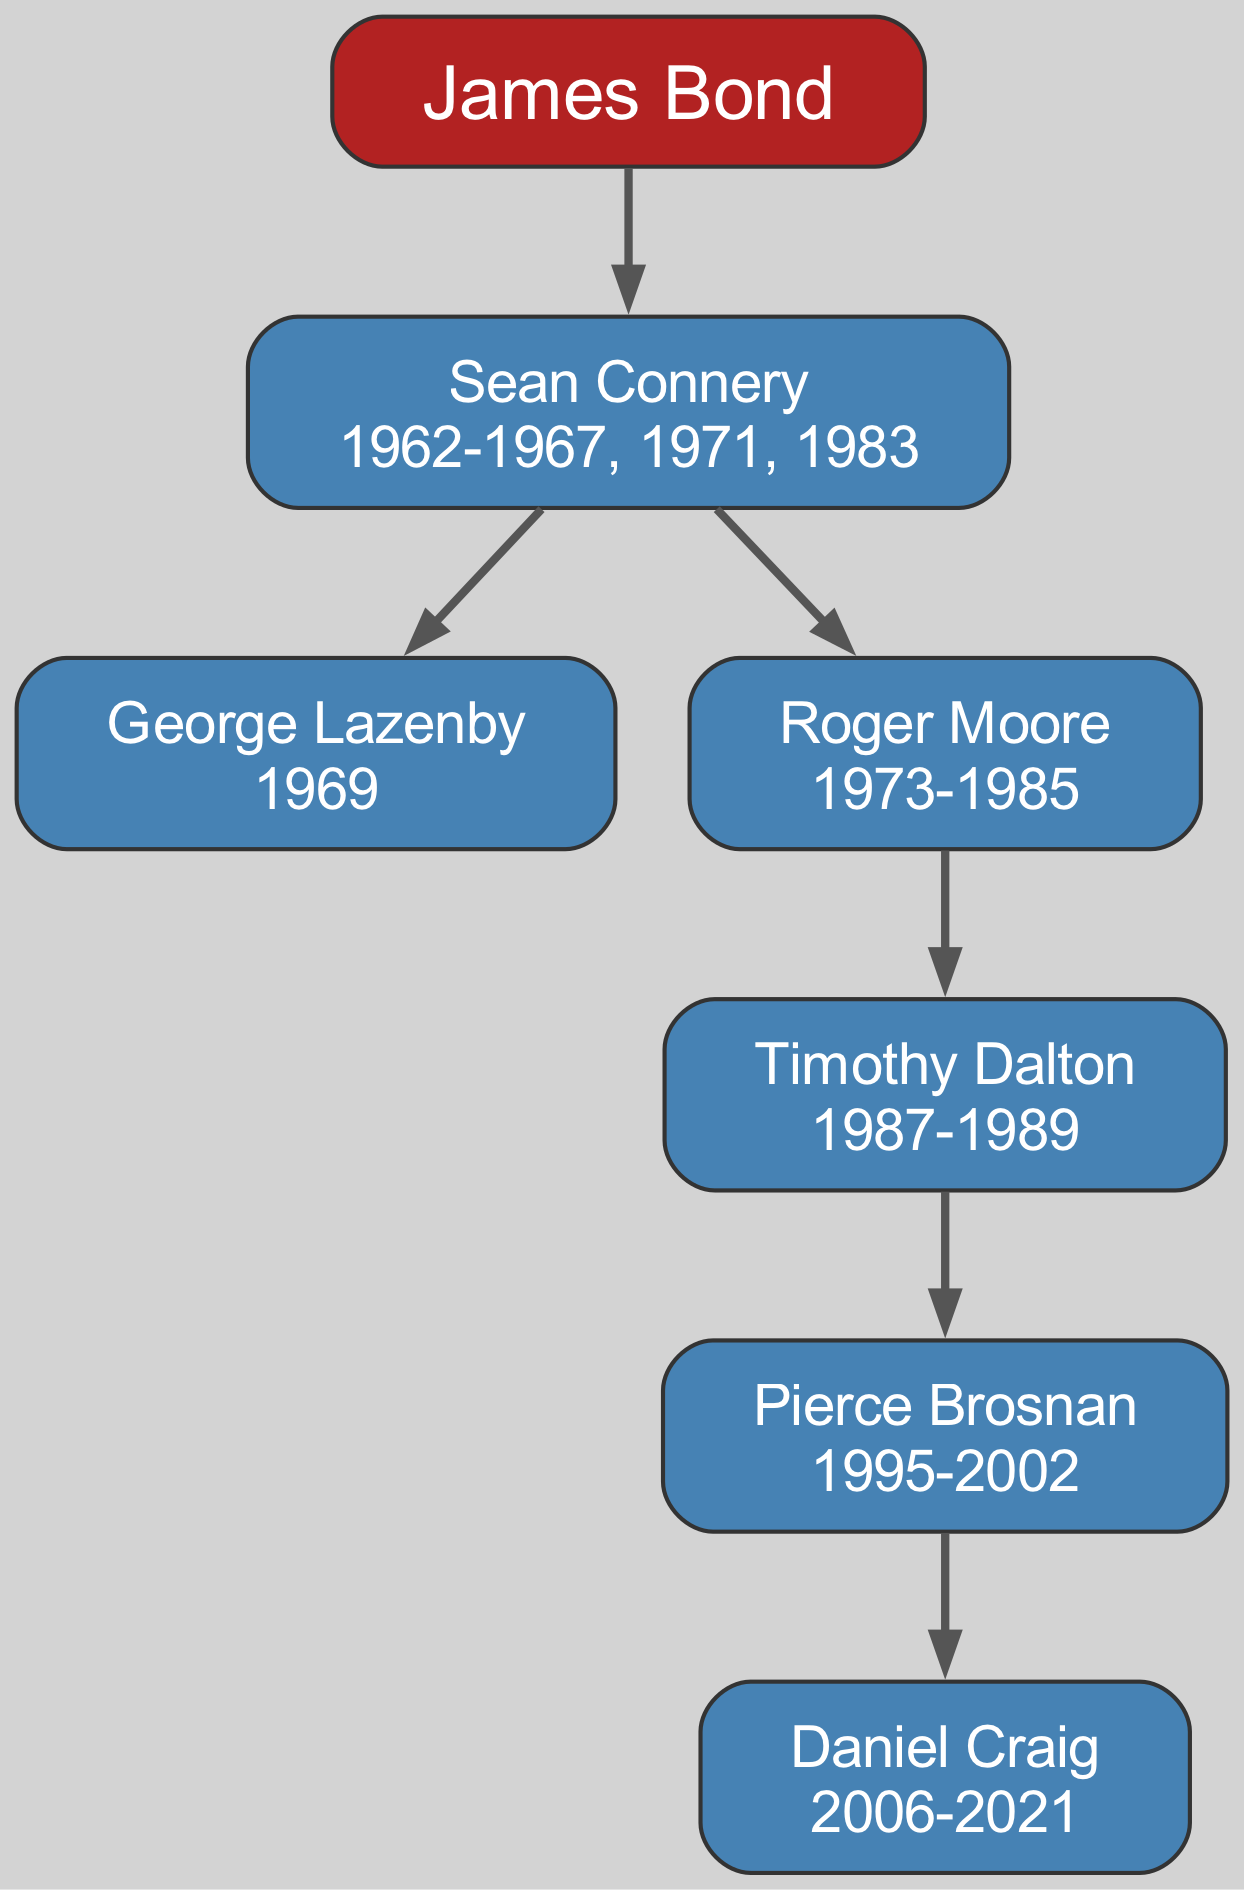What iconic character do these actors portray? The root of the family tree is "James Bond," indicating that all the actors listed are portrayals of this iconic character.
Answer: James Bond How many actors have played James Bond? By tracing the nodes of the diagram from the root to the leaves, we can count the distinct actors: Sean Connery, George Lazenby, Roger Moore, Timothy Dalton, Pierce Brosnan, and Daniel Craig. This totals six actors.
Answer: 6 Who played James Bond before Roger Moore? To find out who portrayed James Bond before Roger Moore, we look at the child nodes of Sean Connery, where George Lazenby is noted as the successor before Roger Moore took over.
Answer: George Lazenby How long did Daniel Craig play James Bond? The years associated with Daniel Craig in the diagram show "2006-2021." To determine the period, we can infer he played the role for approximately 15 years.
Answer: 15 years Which actor has the longest tenure as James Bond? Looking at the years associated with each actor, Sean Connery has the longest coverage of "1962-1967, 1971, 1983," totaling around 7 years, which is longer than others except for perhaps Roger Moore, who spans from "1973-1985." After calculating, Roger Moore's total is 12 years, which is longer than Connery’s.
Answer: Roger Moore How many generations of actors are showcased in this family tree? The diagram lists only one generation directly under the root node of "James Bond," as all actors (children of Connery) are displayed in a single lineage.
Answer: 1 generation What years did Sean Connery first portray James Bond? The years attributed to Sean Connery are listed as "1962-1967, 1971, 1983." Therefore, his first portrayal year is identified as 1962.
Answer: 1962 Who succeeded Timothy Dalton as James Bond? Following Timothy Dalton, we look at his child node in the diagram, which shows Pierce Brosnan as the next actor to take on the role after him.
Answer: Pierce Brosnan 